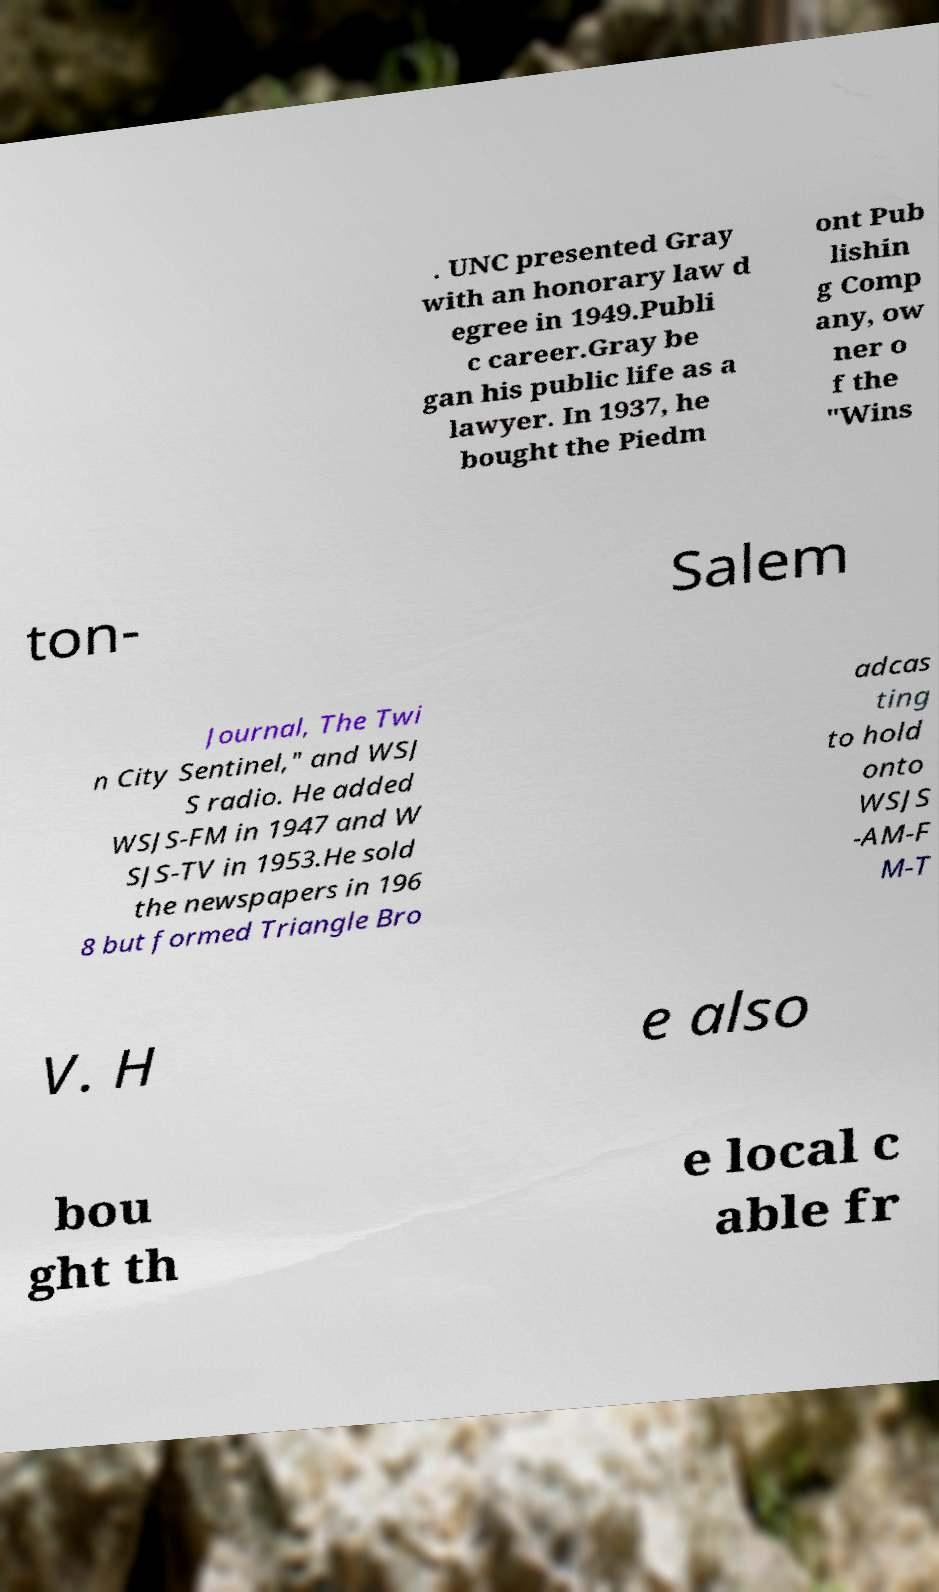Can you read and provide the text displayed in the image?This photo seems to have some interesting text. Can you extract and type it out for me? . UNC presented Gray with an honorary law d egree in 1949.Publi c career.Gray be gan his public life as a lawyer. In 1937, he bought the Piedm ont Pub lishin g Comp any, ow ner o f the "Wins ton- Salem Journal, The Twi n City Sentinel," and WSJ S radio. He added WSJS-FM in 1947 and W SJS-TV in 1953.He sold the newspapers in 196 8 but formed Triangle Bro adcas ting to hold onto WSJS -AM-F M-T V. H e also bou ght th e local c able fr 